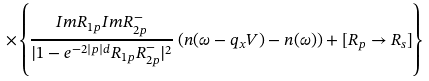Convert formula to latex. <formula><loc_0><loc_0><loc_500><loc_500>\times \left \{ \frac { I m R _ { 1 p } I m R _ { 2 p } ^ { - } } { | 1 - e ^ { - 2 | p | d } R _ { 1 p } R _ { 2 p } ^ { - } | ^ { 2 } } \left ( n ( \omega - q _ { x } V ) - n ( \omega ) \right ) + [ R _ { p } \rightarrow R _ { s } ] \right \}</formula> 